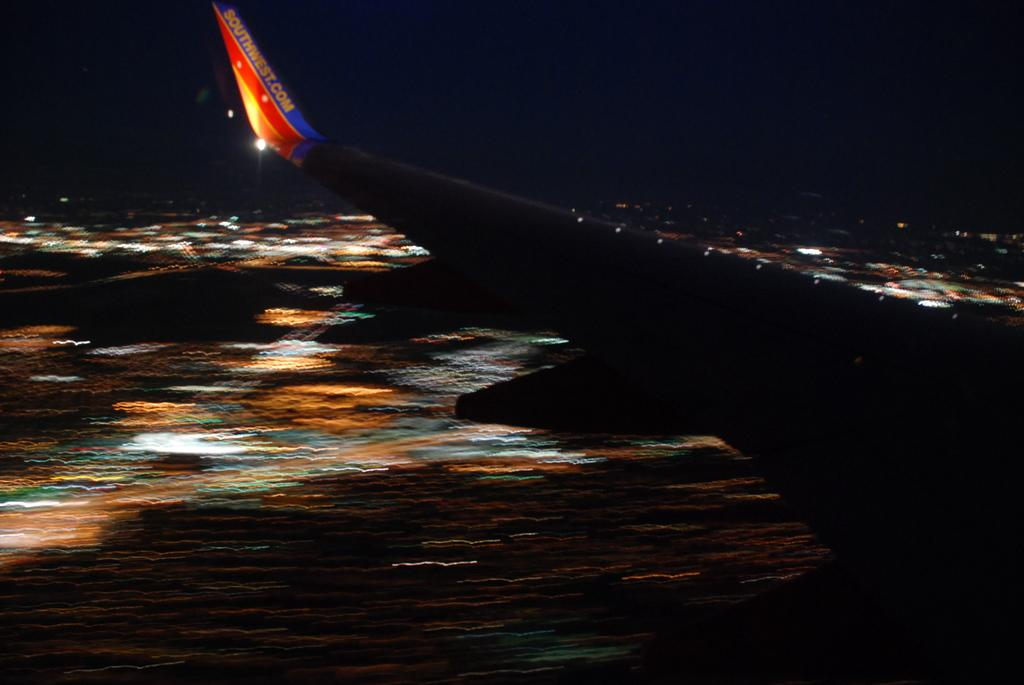<image>
Summarize the visual content of the image. A Southwest airline airplane takes off from the runway at night. 